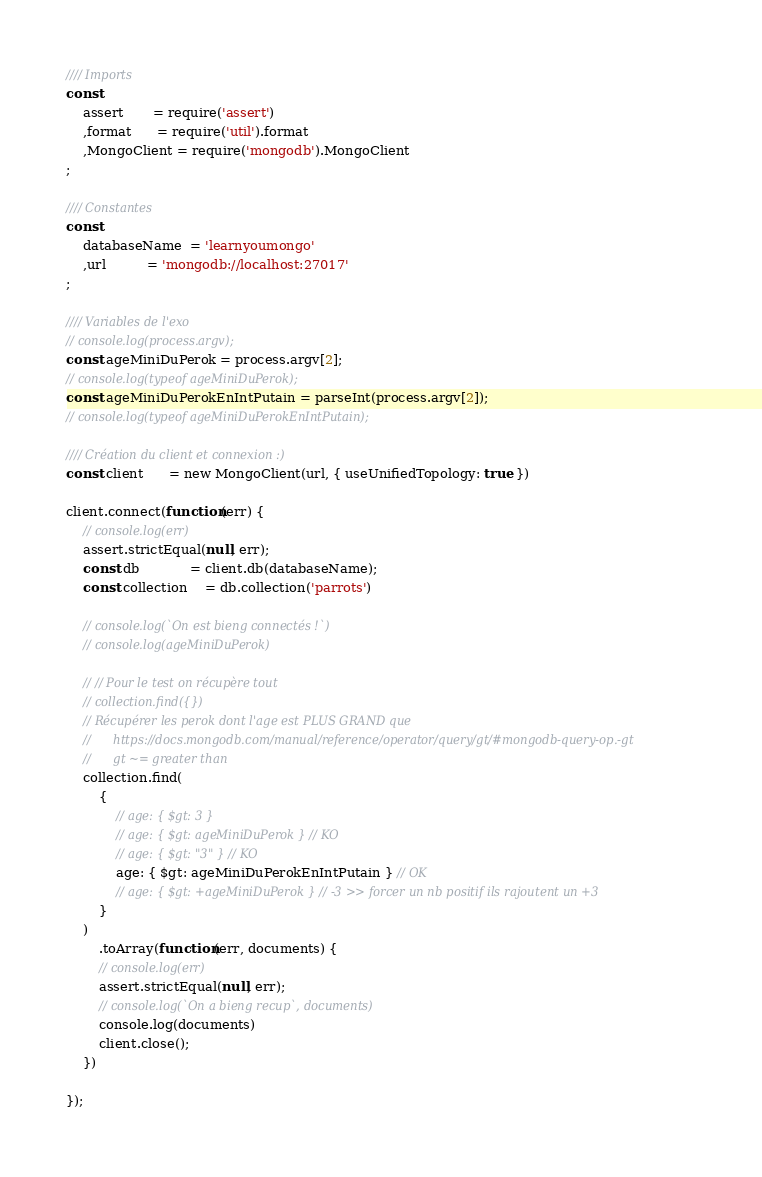<code> <loc_0><loc_0><loc_500><loc_500><_JavaScript_>//// Imports
const 
    assert       = require('assert')
    ,format      = require('util').format
    ,MongoClient = require('mongodb').MongoClient
;

//// Constantes
const 
    databaseName  = 'learnyoumongo'
    ,url          = 'mongodb://localhost:27017'
;

//// Variables de l'exo
// console.log(process.argv);
const ageMiniDuPerok = process.argv[2];
// console.log(typeof ageMiniDuPerok);
const ageMiniDuPerokEnIntPutain = parseInt(process.argv[2]);
// console.log(typeof ageMiniDuPerokEnIntPutain);

//// Création du client et connexion :)
const client      = new MongoClient(url, { useUnifiedTopology: true })

client.connect(function(err) {
    // console.log(err)
    assert.strictEqual(null, err);
    const db            = client.db(databaseName);
    const collection    = db.collection('parrots')
    
    // console.log(`On est bieng connectés !`)
    // console.log(ageMiniDuPerok)
    
    // // Pour le test on récupère tout
    // collection.find({})
    // Récupérer les perok dont l'age est PLUS GRAND que
    //      https://docs.mongodb.com/manual/reference/operator/query/gt/#mongodb-query-op.-gt
    //      gt ~= greater than
    collection.find(
        { 
            // age: { $gt: 3 }
            // age: { $gt: ageMiniDuPerok } // KO
            // age: { $gt: "3" } // KO
            age: { $gt: ageMiniDuPerokEnIntPutain } // OK
            // age: { $gt: +ageMiniDuPerok } // -3 >> forcer un nb positif ils rajoutent un +3
        }
    )
        .toArray(function(err, documents) {
        // console.log(err)
        assert.strictEqual(null, err);
        // console.log(`On a bieng recup`, documents)
        console.log(documents)
        client.close();
    })

});
</code> 